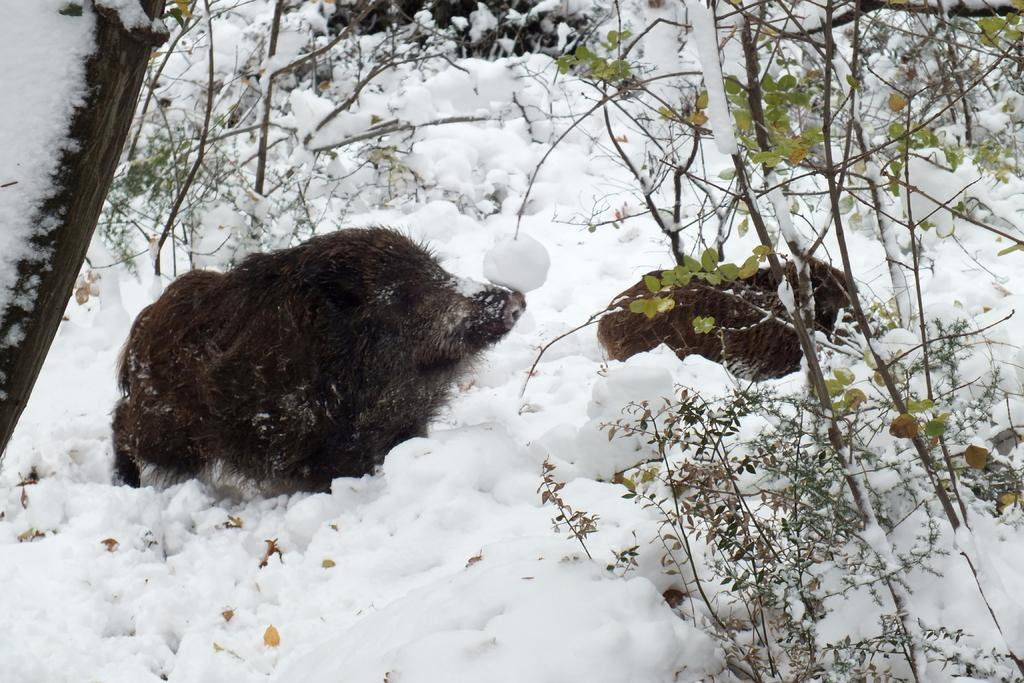What type of animals can be seen in the image? There are animals in the image. What is the environment in which the animals are located? The animals are in the snow. What else is present in the image besides the animals? There are in the snow? What type of drug is the animal holding in the image? There is no drug present in the image. 